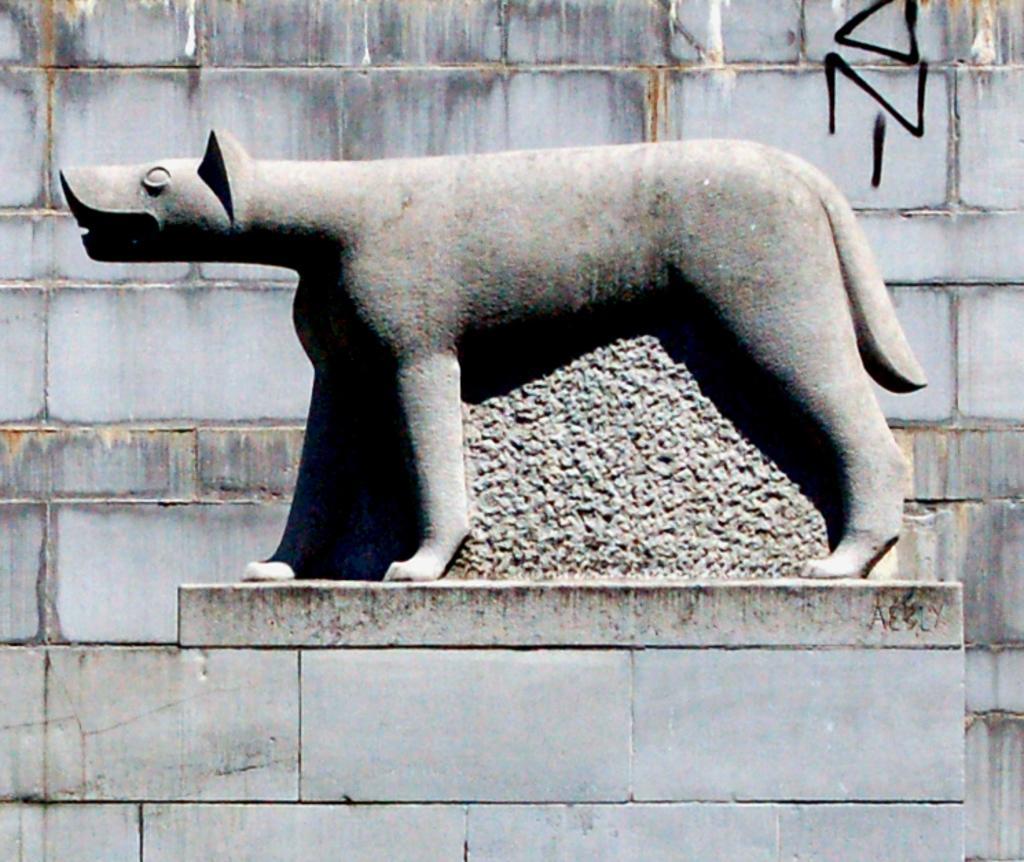Could you give a brief overview of what you see in this image? Here I can see a statue on a pillar. In the background there is a wall. 